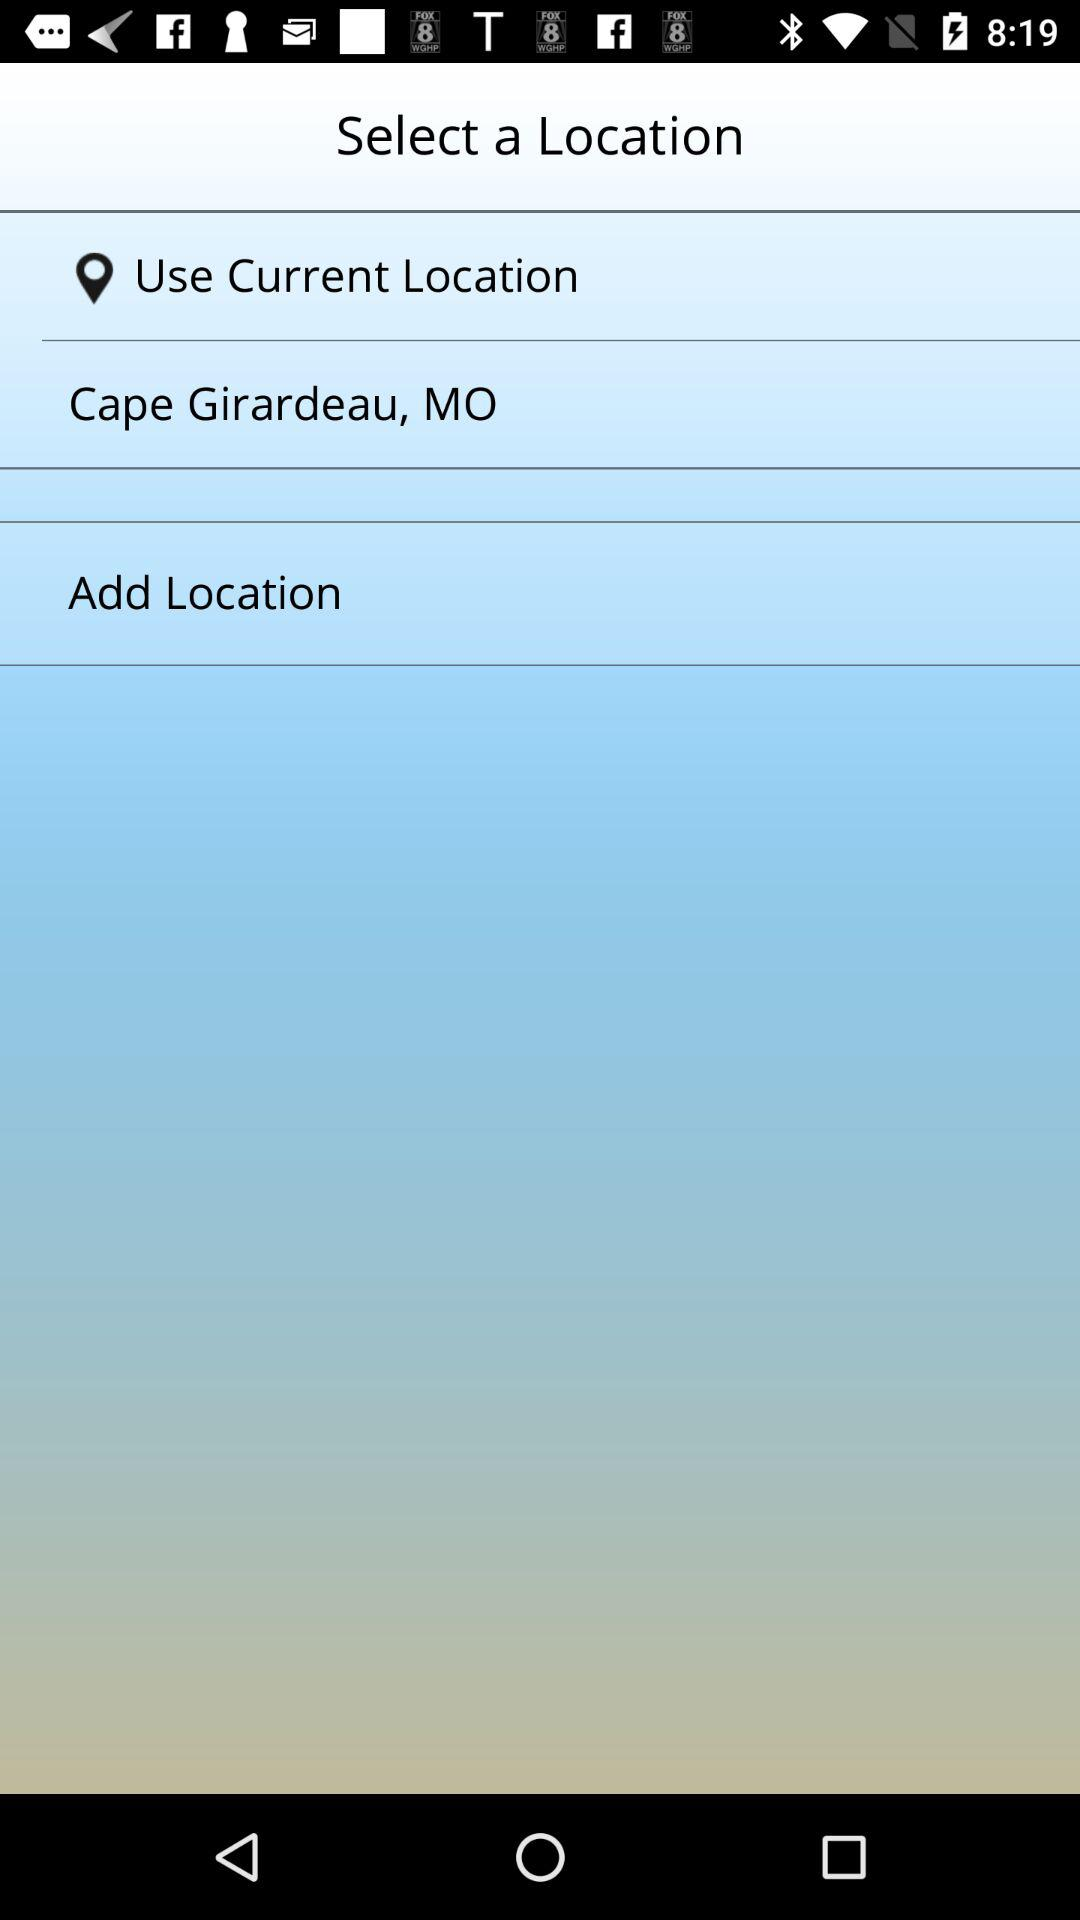What is the selected current location? The selected current location is Cape Girardeau, MO. 